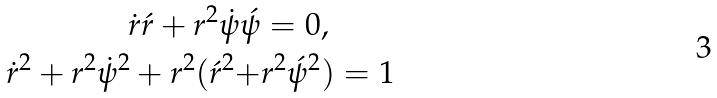Convert formula to latex. <formula><loc_0><loc_0><loc_500><loc_500>\dot { r } \acute { r } + r ^ { 2 } \dot { \psi } \acute { \psi } & = 0 , \\ \dot { r } ^ { 2 } + { r } ^ { 2 } \dot { \psi } ^ { 2 } + { r } ^ { 2 } ( { \acute { r } } ^ { 2 } + & { r } ^ { 2 } \acute { \psi } ^ { 2 } ) = 1</formula> 